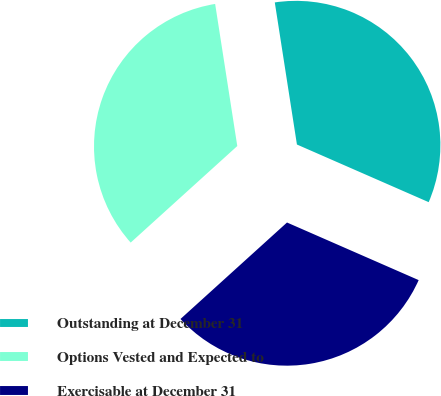Convert chart to OTSL. <chart><loc_0><loc_0><loc_500><loc_500><pie_chart><fcel>Outstanding at December 31<fcel>Options Vested and Expected to<fcel>Exercisable at December 31<nl><fcel>34.02%<fcel>34.25%<fcel>31.72%<nl></chart> 